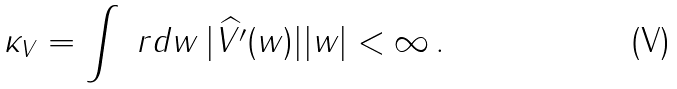<formula> <loc_0><loc_0><loc_500><loc_500>\kappa _ { V } = \int \ r d w \, | \widehat { V ^ { \prime } } ( w ) | | w | < \infty \, .</formula> 